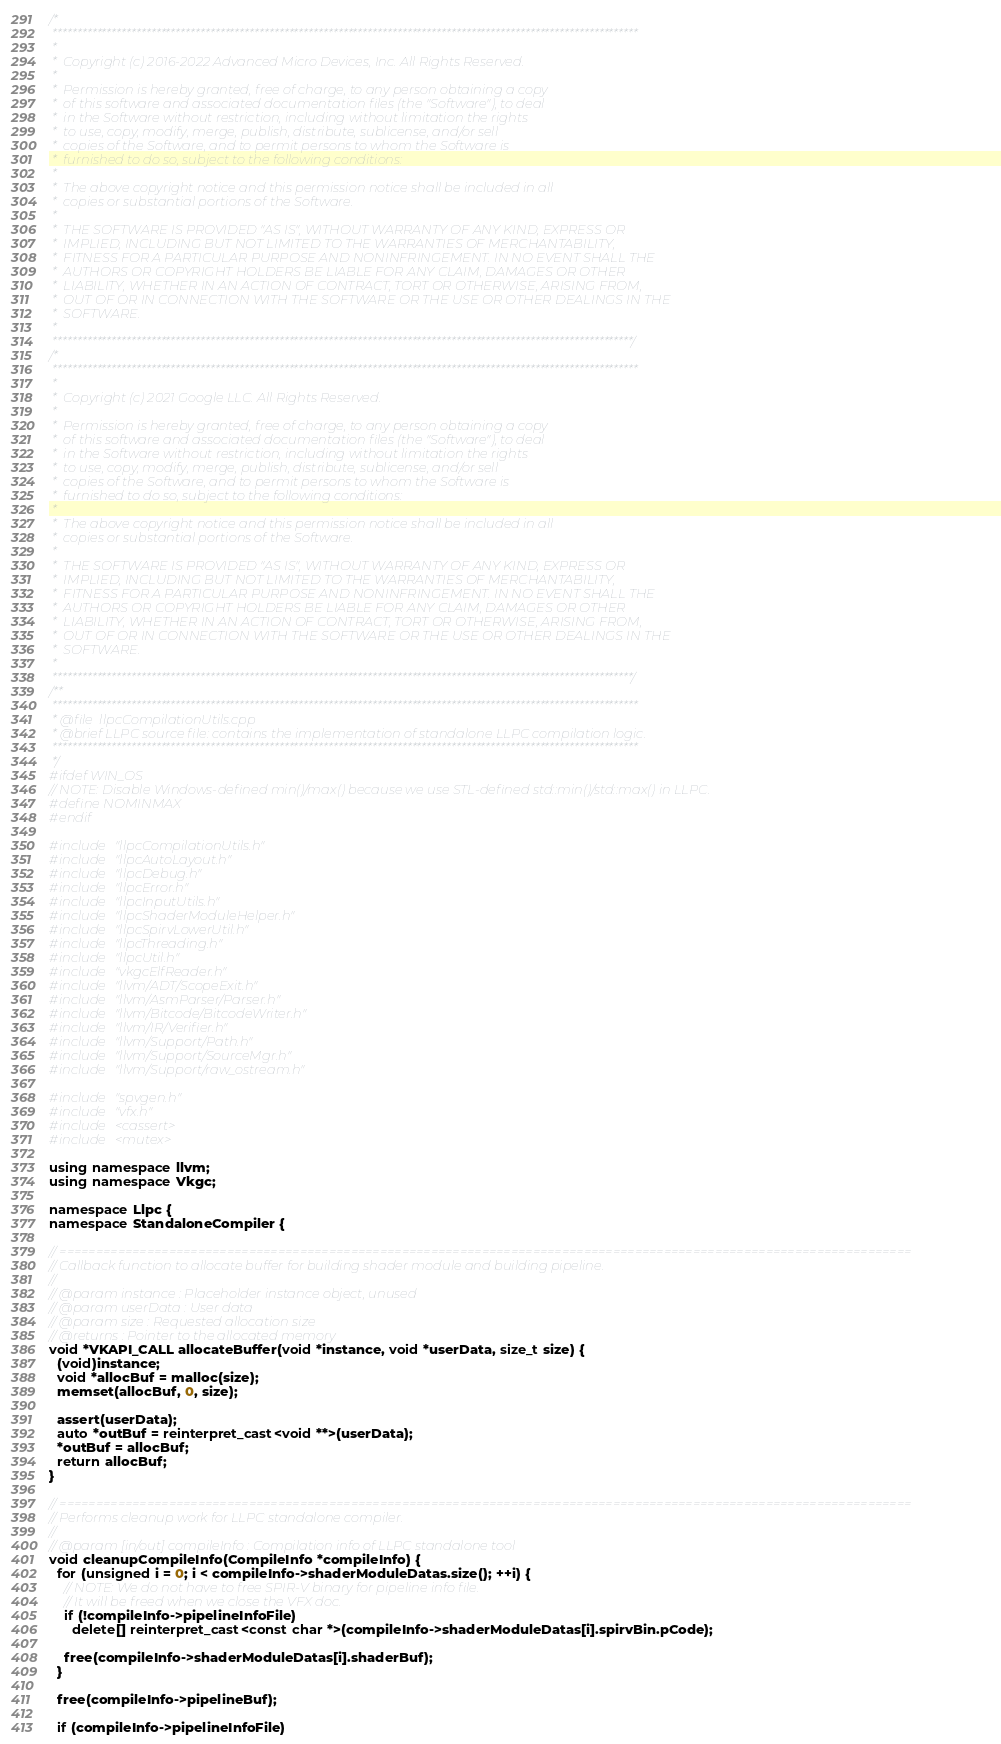<code> <loc_0><loc_0><loc_500><loc_500><_C++_>/*
 ***********************************************************************************************************************
 *
 *  Copyright (c) 2016-2022 Advanced Micro Devices, Inc. All Rights Reserved.
 *
 *  Permission is hereby granted, free of charge, to any person obtaining a copy
 *  of this software and associated documentation files (the "Software"), to deal
 *  in the Software without restriction, including without limitation the rights
 *  to use, copy, modify, merge, publish, distribute, sublicense, and/or sell
 *  copies of the Software, and to permit persons to whom the Software is
 *  furnished to do so, subject to the following conditions:
 *
 *  The above copyright notice and this permission notice shall be included in all
 *  copies or substantial portions of the Software.
 *
 *  THE SOFTWARE IS PROVIDED "AS IS", WITHOUT WARRANTY OF ANY KIND, EXPRESS OR
 *  IMPLIED, INCLUDING BUT NOT LIMITED TO THE WARRANTIES OF MERCHANTABILITY,
 *  FITNESS FOR A PARTICULAR PURPOSE AND NONINFRINGEMENT. IN NO EVENT SHALL THE
 *  AUTHORS OR COPYRIGHT HOLDERS BE LIABLE FOR ANY CLAIM, DAMAGES OR OTHER
 *  LIABILITY, WHETHER IN AN ACTION OF CONTRACT, TORT OR OTHERWISE, ARISING FROM,
 *  OUT OF OR IN CONNECTION WITH THE SOFTWARE OR THE USE OR OTHER DEALINGS IN THE
 *  SOFTWARE.
 *
 **********************************************************************************************************************/
/*
 ***********************************************************************************************************************
 *
 *  Copyright (c) 2021 Google LLC. All Rights Reserved.
 *
 *  Permission is hereby granted, free of charge, to any person obtaining a copy
 *  of this software and associated documentation files (the "Software"), to deal
 *  in the Software without restriction, including without limitation the rights
 *  to use, copy, modify, merge, publish, distribute, sublicense, and/or sell
 *  copies of the Software, and to permit persons to whom the Software is
 *  furnished to do so, subject to the following conditions:
 *
 *  The above copyright notice and this permission notice shall be included in all
 *  copies or substantial portions of the Software.
 *
 *  THE SOFTWARE IS PROVIDED "AS IS", WITHOUT WARRANTY OF ANY KIND, EXPRESS OR
 *  IMPLIED, INCLUDING BUT NOT LIMITED TO THE WARRANTIES OF MERCHANTABILITY,
 *  FITNESS FOR A PARTICULAR PURPOSE AND NONINFRINGEMENT. IN NO EVENT SHALL THE
 *  AUTHORS OR COPYRIGHT HOLDERS BE LIABLE FOR ANY CLAIM, DAMAGES OR OTHER
 *  LIABILITY, WHETHER IN AN ACTION OF CONTRACT, TORT OR OTHERWISE, ARISING FROM,
 *  OUT OF OR IN CONNECTION WITH THE SOFTWARE OR THE USE OR OTHER DEALINGS IN THE
 *  SOFTWARE.
 *
 **********************************************************************************************************************/
/**
 ***********************************************************************************************************************
 * @file  llpcCompilationUtils.cpp
 * @brief LLPC source file: contains the implementation of standalone LLPC compilation logic.
 ***********************************************************************************************************************
 */
#ifdef WIN_OS
// NOTE: Disable Windows-defined min()/max() because we use STL-defined std::min()/std::max() in LLPC.
#define NOMINMAX
#endif

#include "llpcCompilationUtils.h"
#include "llpcAutoLayout.h"
#include "llpcDebug.h"
#include "llpcError.h"
#include "llpcInputUtils.h"
#include "llpcShaderModuleHelper.h"
#include "llpcSpirvLowerUtil.h"
#include "llpcThreading.h"
#include "llpcUtil.h"
#include "vkgcElfReader.h"
#include "llvm/ADT/ScopeExit.h"
#include "llvm/AsmParser/Parser.h"
#include "llvm/Bitcode/BitcodeWriter.h"
#include "llvm/IR/Verifier.h"
#include "llvm/Support/Path.h"
#include "llvm/Support/SourceMgr.h"
#include "llvm/Support/raw_ostream.h"

#include "spvgen.h"
#include "vfx.h"
#include <cassert>
#include <mutex>

using namespace llvm;
using namespace Vkgc;

namespace Llpc {
namespace StandaloneCompiler {

// =====================================================================================================================
// Callback function to allocate buffer for building shader module and building pipeline.
//
// @param instance : Placeholder instance object, unused
// @param userData : User data
// @param size : Requested allocation size
// @returns : Pointer to the allocated memory
void *VKAPI_CALL allocateBuffer(void *instance, void *userData, size_t size) {
  (void)instance;
  void *allocBuf = malloc(size);
  memset(allocBuf, 0, size);

  assert(userData);
  auto *outBuf = reinterpret_cast<void **>(userData);
  *outBuf = allocBuf;
  return allocBuf;
}

// =====================================================================================================================
// Performs cleanup work for LLPC standalone compiler.
//
// @param [in/out] compileInfo : Compilation info of LLPC standalone tool
void cleanupCompileInfo(CompileInfo *compileInfo) {
  for (unsigned i = 0; i < compileInfo->shaderModuleDatas.size(); ++i) {
    // NOTE: We do not have to free SPIR-V binary for pipeline info file.
    // It will be freed when we close the VFX doc.
    if (!compileInfo->pipelineInfoFile)
      delete[] reinterpret_cast<const char *>(compileInfo->shaderModuleDatas[i].spirvBin.pCode);

    free(compileInfo->shaderModuleDatas[i].shaderBuf);
  }

  free(compileInfo->pipelineBuf);

  if (compileInfo->pipelineInfoFile)</code> 